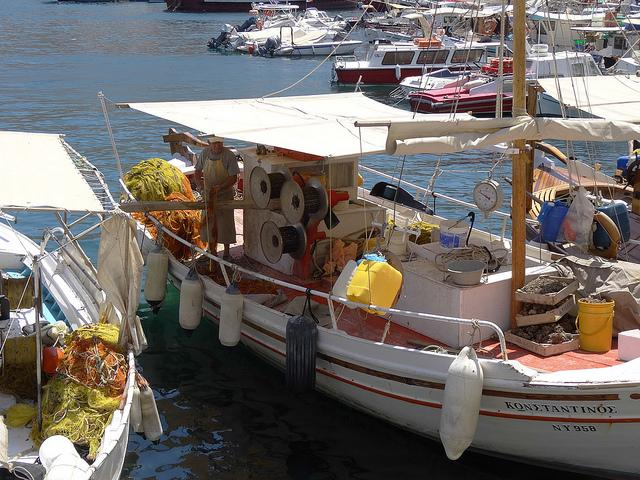What sort of method is used to secure these vessels to the shore? Please explain your reasoning. knots. The boat has ropes on the sides that can be tied in knots to secure it to the dock. 